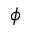Convert formula to latex. <formula><loc_0><loc_0><loc_500><loc_500>\phi</formula> 